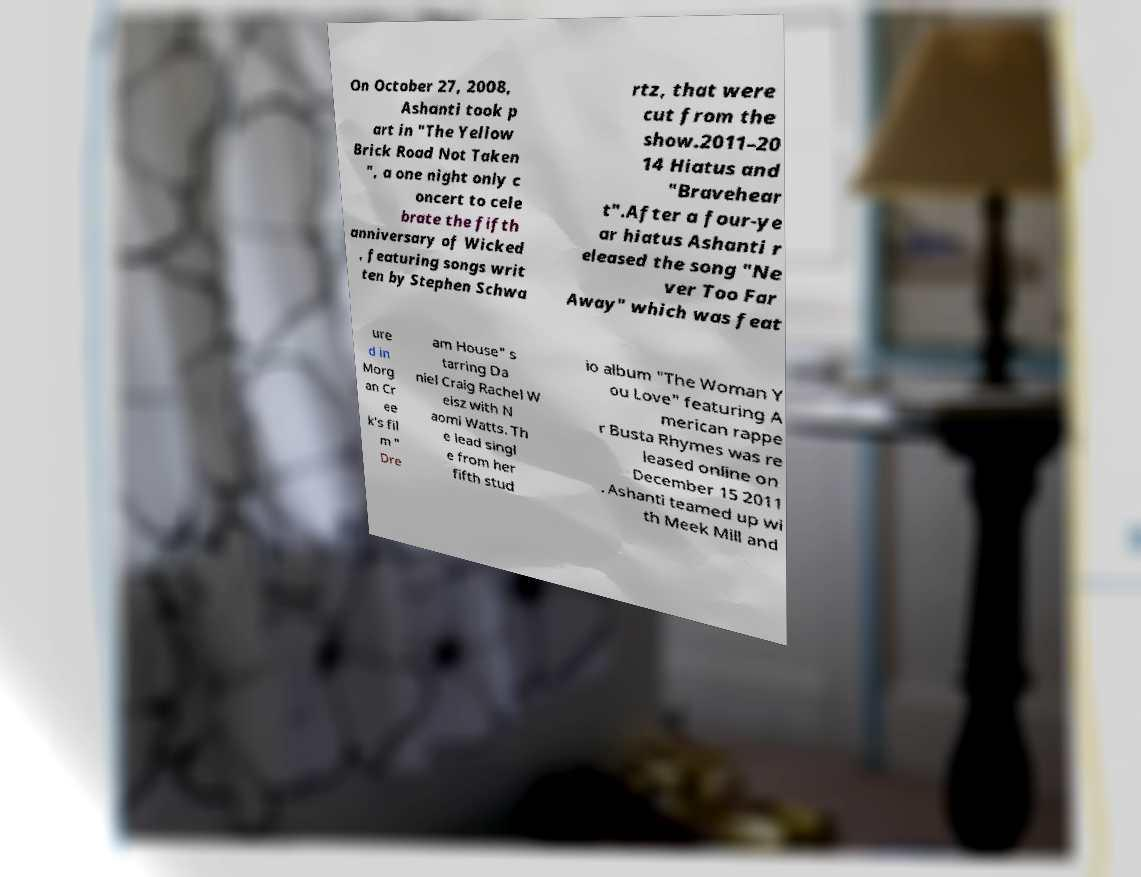Could you extract and type out the text from this image? On October 27, 2008, Ashanti took p art in "The Yellow Brick Road Not Taken ", a one night only c oncert to cele brate the fifth anniversary of Wicked , featuring songs writ ten by Stephen Schwa rtz, that were cut from the show.2011–20 14 Hiatus and "Bravehear t".After a four-ye ar hiatus Ashanti r eleased the song "Ne ver Too Far Away" which was feat ure d in Morg an Cr ee k's fil m " Dre am House" s tarring Da niel Craig Rachel W eisz with N aomi Watts. Th e lead singl e from her fifth stud io album "The Woman Y ou Love" featuring A merican rappe r Busta Rhymes was re leased online on December 15 2011 . Ashanti teamed up wi th Meek Mill and 